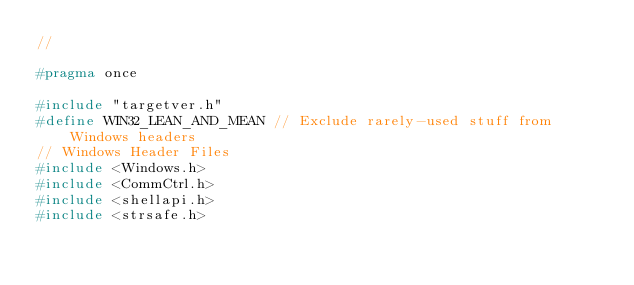Convert code to text. <code><loc_0><loc_0><loc_500><loc_500><_C_>//

#pragma once

#include "targetver.h"
#define WIN32_LEAN_AND_MEAN // Exclude rarely-used stuff from Windows headers
// Windows Header Files
#include <Windows.h>
#include <CommCtrl.h>
#include <shellapi.h>
#include <strsafe.h>
</code> 